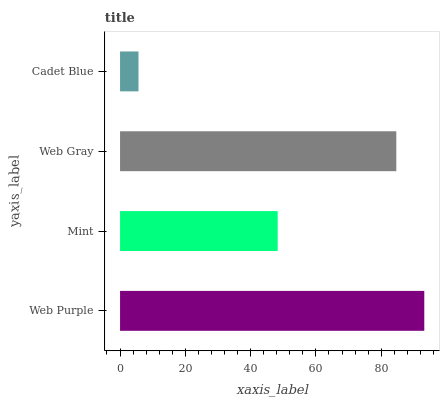Is Cadet Blue the minimum?
Answer yes or no. Yes. Is Web Purple the maximum?
Answer yes or no. Yes. Is Mint the minimum?
Answer yes or no. No. Is Mint the maximum?
Answer yes or no. No. Is Web Purple greater than Mint?
Answer yes or no. Yes. Is Mint less than Web Purple?
Answer yes or no. Yes. Is Mint greater than Web Purple?
Answer yes or no. No. Is Web Purple less than Mint?
Answer yes or no. No. Is Web Gray the high median?
Answer yes or no. Yes. Is Mint the low median?
Answer yes or no. Yes. Is Mint the high median?
Answer yes or no. No. Is Web Purple the low median?
Answer yes or no. No. 